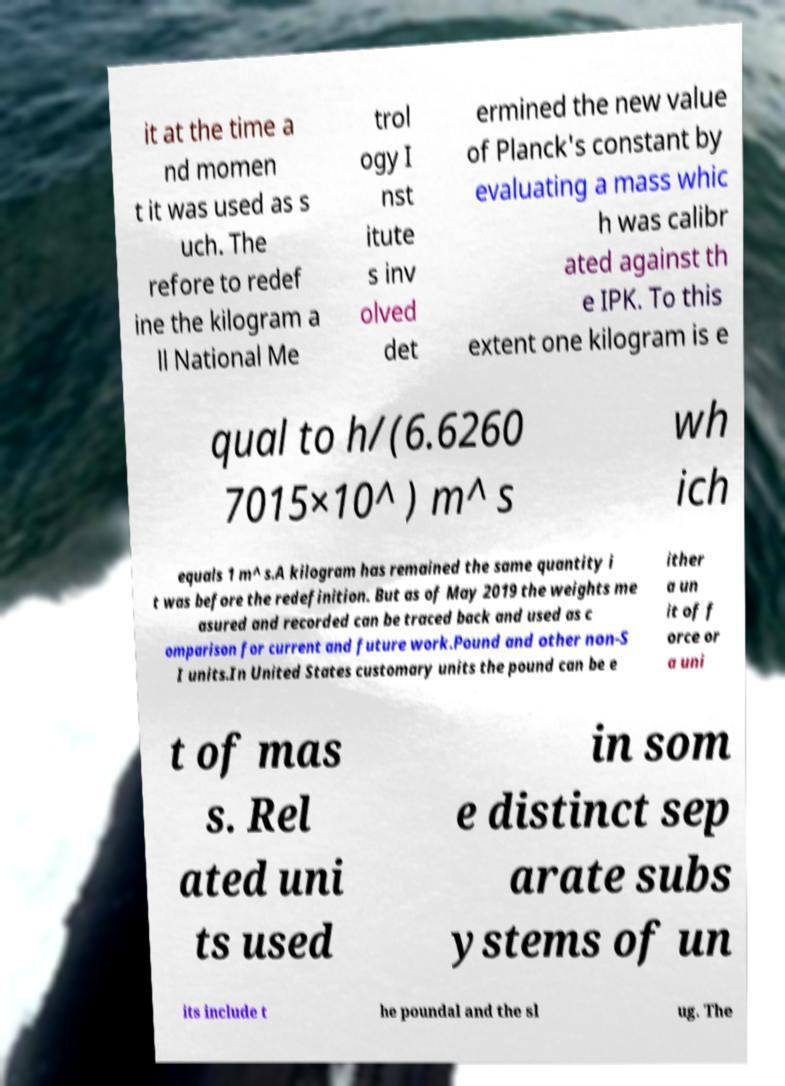Could you extract and type out the text from this image? it at the time a nd momen t it was used as s uch. The refore to redef ine the kilogram a ll National Me trol ogy I nst itute s inv olved det ermined the new value of Planck's constant by evaluating a mass whic h was calibr ated against th e IPK. To this extent one kilogram is e qual to h/(6.6260 7015×10^ ) m^ s wh ich equals 1 m^ s.A kilogram has remained the same quantity i t was before the redefinition. But as of May 2019 the weights me asured and recorded can be traced back and used as c omparison for current and future work.Pound and other non-S I units.In United States customary units the pound can be e ither a un it of f orce or a uni t of mas s. Rel ated uni ts used in som e distinct sep arate subs ystems of un its include t he poundal and the sl ug. The 